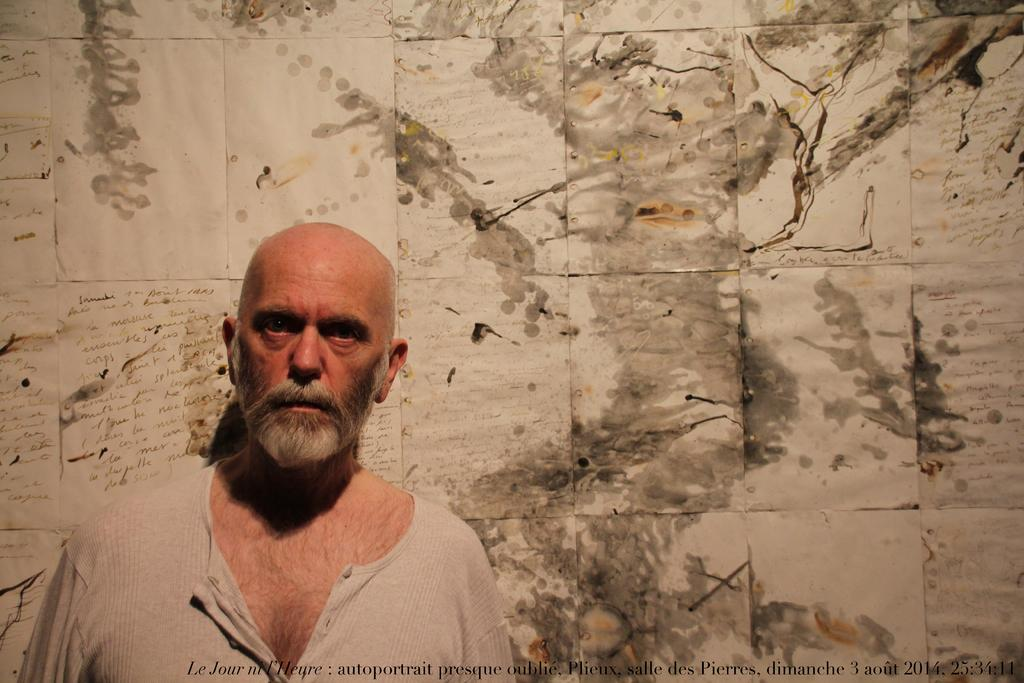Who or what is present in the image? There is a person in the image. What is the person wearing? The person is wearing a cream-colored dress. What can be seen attached to a surface in the image? There are papers attached to a surface in the image. What colors are present on the papers? The papers have colors of cream, black, and brown. What type of farm animals can be seen in the image? There are no farm animals present in the image. What kind of loaf is being prepared by the person in the image? There is no loaf or baking activity depicted in the image. 